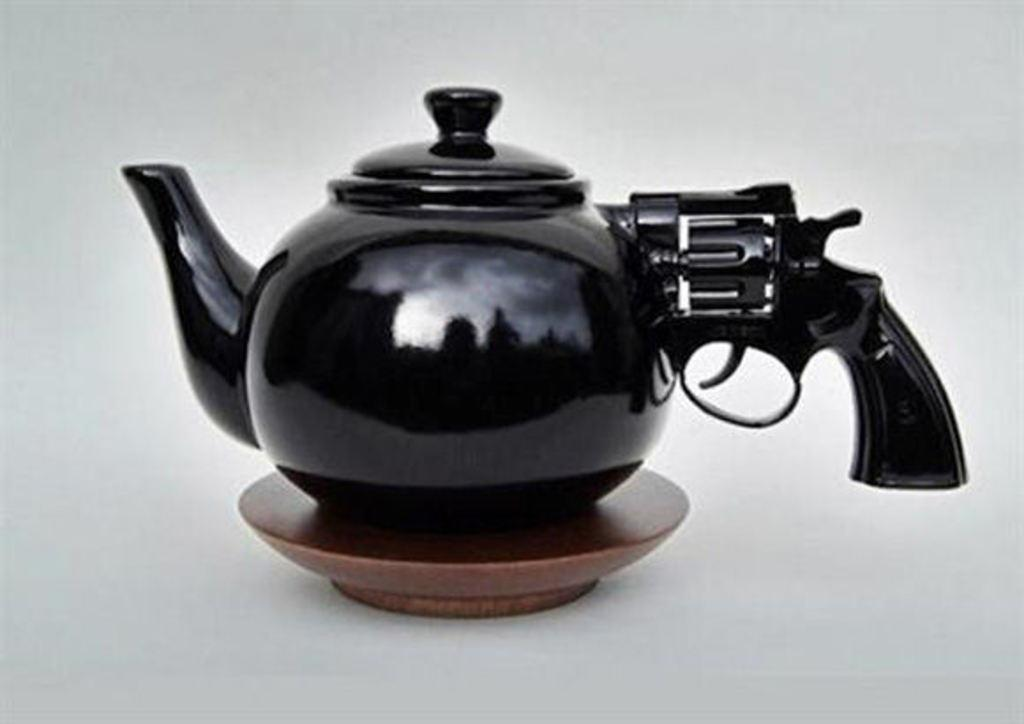What color is the kettle in the image? The kettle in the image is black-colored. Where is the kettle located in the image? The kettle is present on a plate in the image. What is the kettle placed on in the image? The plate is placed over a surface in the image. How is the kettle's handle designed? The kettle's handle is shaped like a gun trigger in the image. What type of lace can be seen on the boys' clothing at the farm in the image? There is no mention of boys, clothing, or a farm in the image; it features a black-colored kettle on a plate. 